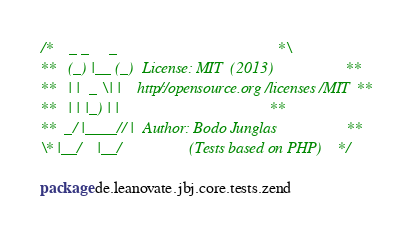Convert code to text. <code><loc_0><loc_0><loc_500><loc_500><_Scala_>/*    _ _     _                                        *\
**   (_) |__ (_)  License: MIT  (2013)                 **
**   | |  _ \| |    http://opensource.org/licenses/MIT **
**   | | |_) | |                                       **
**  _/ |____// |  Author: Bodo Junglas                 **
\* |__/    |__/                 (Tests based on PHP)   */

package de.leanovate.jbj.core.tests.zend
</code> 